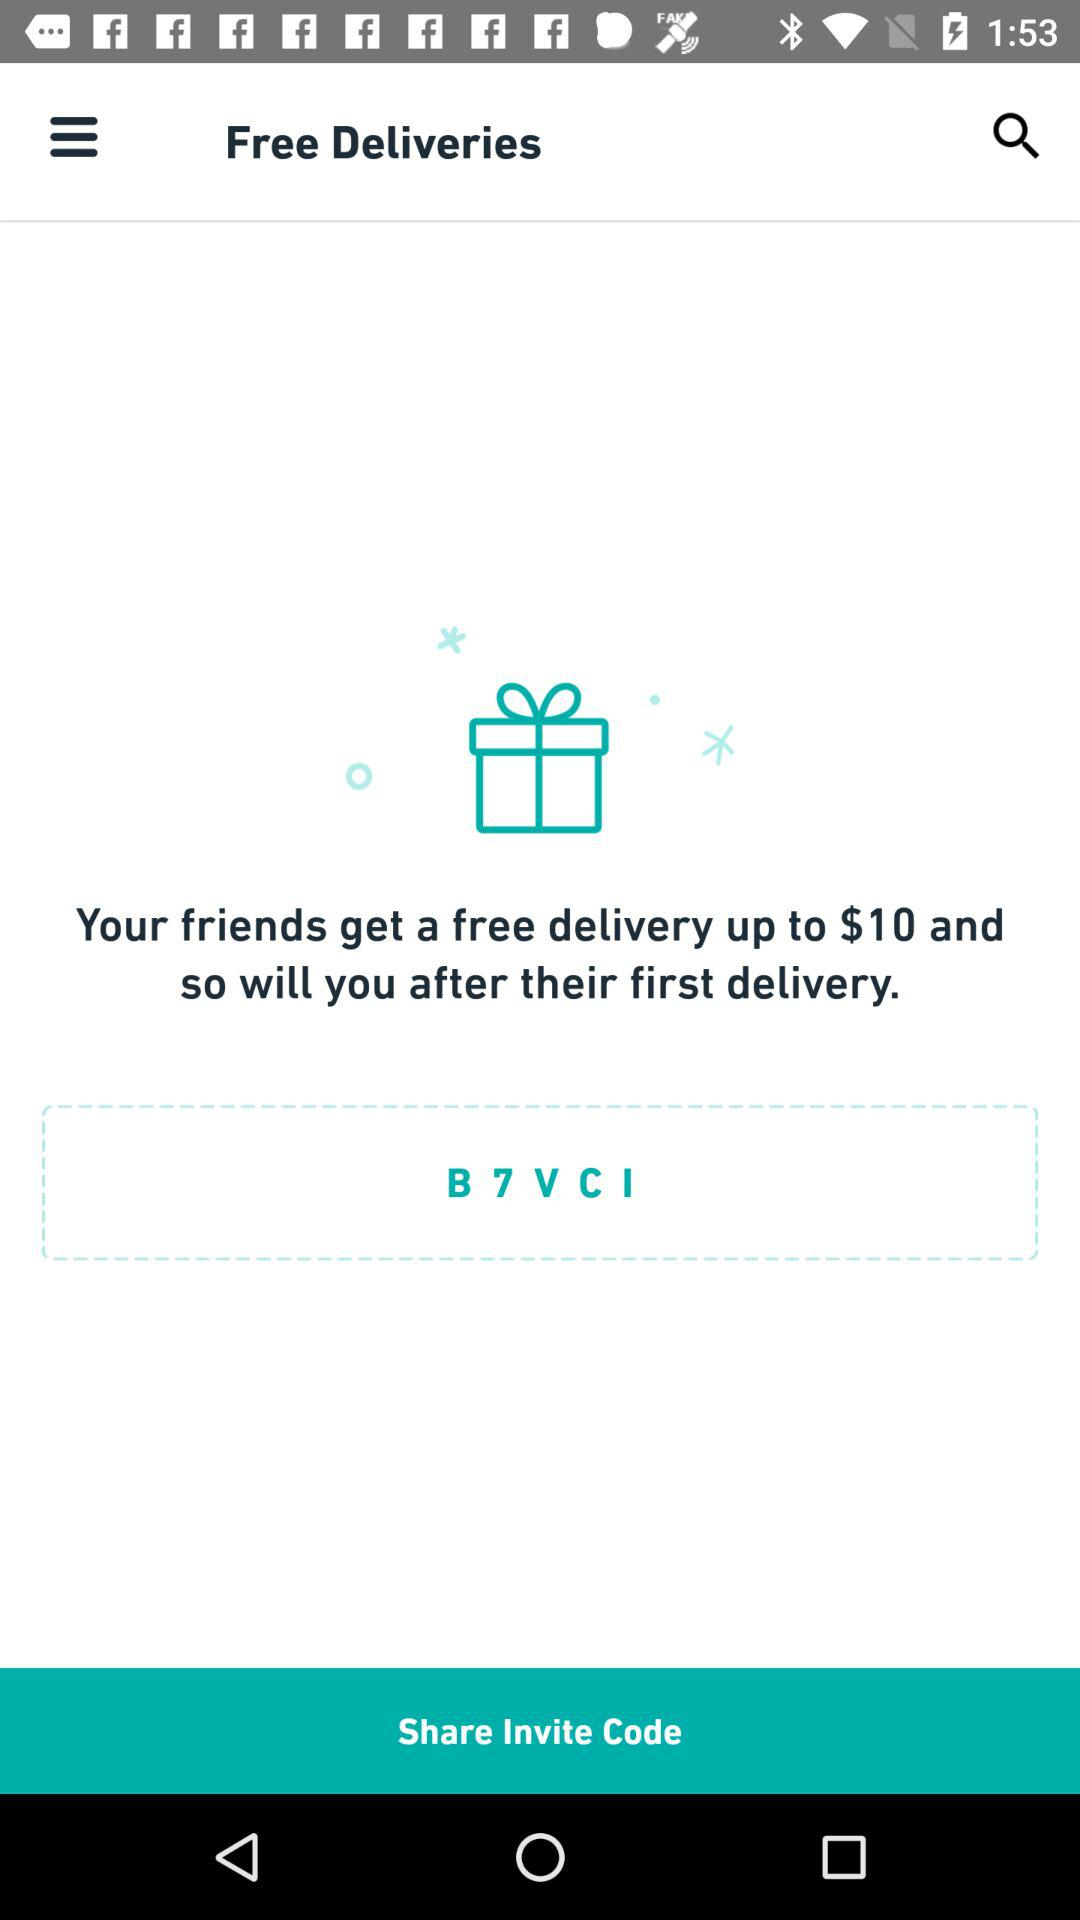What is the currency of the amount? The currency is the dollar. 